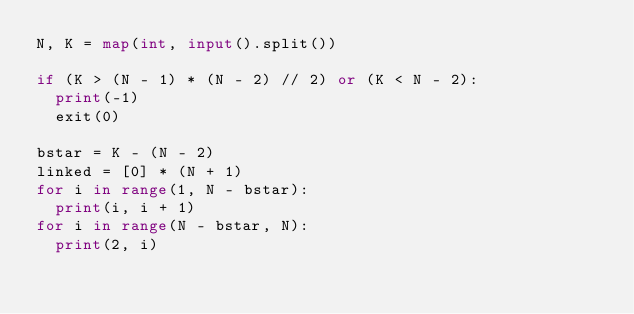Convert code to text. <code><loc_0><loc_0><loc_500><loc_500><_Python_>N, K = map(int, input().split())

if (K > (N - 1) * (N - 2) // 2) or (K < N - 2):
  print(-1)
  exit(0)

bstar = K - (N - 2)
linked = [0] * (N + 1)
for i in range(1, N - bstar):
  print(i, i + 1)
for i in range(N - bstar, N):
  print(2, i)</code> 